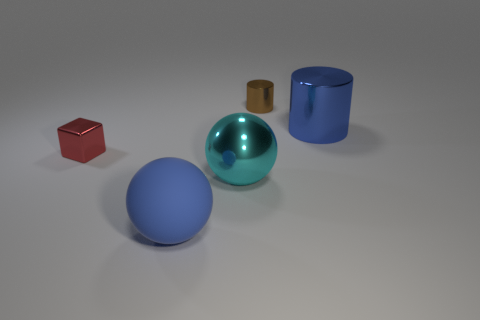Add 1 red cubes. How many objects exist? 6 Subtract all blue balls. How many balls are left? 1 Add 5 large cyan objects. How many large cyan objects exist? 6 Subtract 0 red balls. How many objects are left? 5 Subtract all blocks. How many objects are left? 4 Subtract all blue cubes. Subtract all green cylinders. How many cubes are left? 1 Subtract all yellow spheres. How many cyan cylinders are left? 0 Subtract all tiny yellow metallic things. Subtract all blue rubber spheres. How many objects are left? 4 Add 5 tiny red blocks. How many tiny red blocks are left? 6 